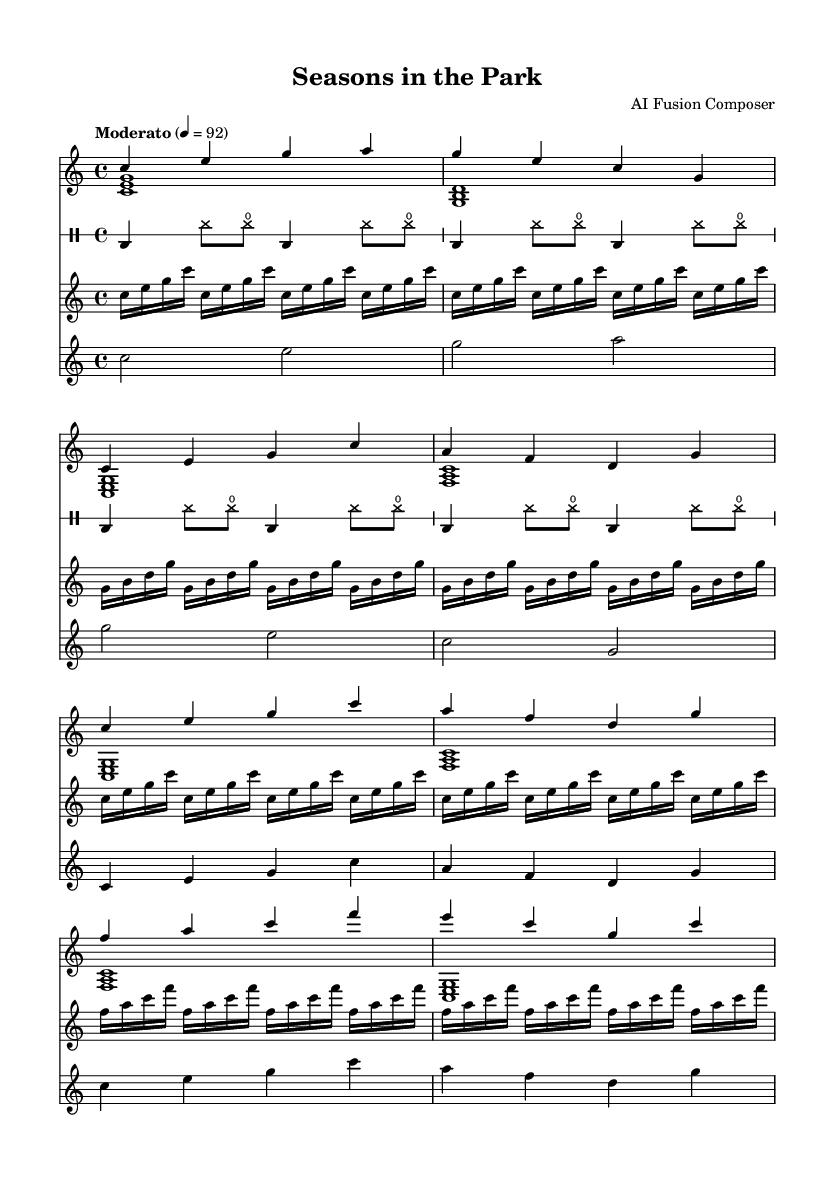What is the key signature of this music? The key signature is C major, which has no sharps or flats.
Answer: C major What is the time signature of this music? The time signature is located at the beginning of the sheet music, indicated as 4/4, meaning there are four beats in a measure and the quarter note gets one beat.
Answer: 4/4 What is the tempo marking for this composition? The tempo marking is displayed in the score as "Moderato" with a metronome marking of 92, suggesting a moderate tempo.
Answer: Moderato 4 = 92 How many measures are in the piano right-hand part? By counting the number of distinct lines through the music for the right-hand voice, we find that there are 8 measures in total.
Answer: 8 In which section does the bridge occur? The bridge appears in the score after the verse and chorus sections, consisting of specific notes that are designated as the bridge. It can be identified as the section with the notes F A C F and E C G C.
Answer: Bridge What kind of rhythm pattern does the drums use? The drum part features a four-on-the-floor pattern, characterized by a bass drum on every beat along with syncopated hi-hats, indicated with specific notations in the music sheet.
Answer: Four-on-the-floor What type of instrument(s) are used in this composition? The composition features a piano, synthesizer, violin, and a drum part, as indicated by the separate staves labeled for each instrument.
Answer: Piano, synthesizer, violin, drums 